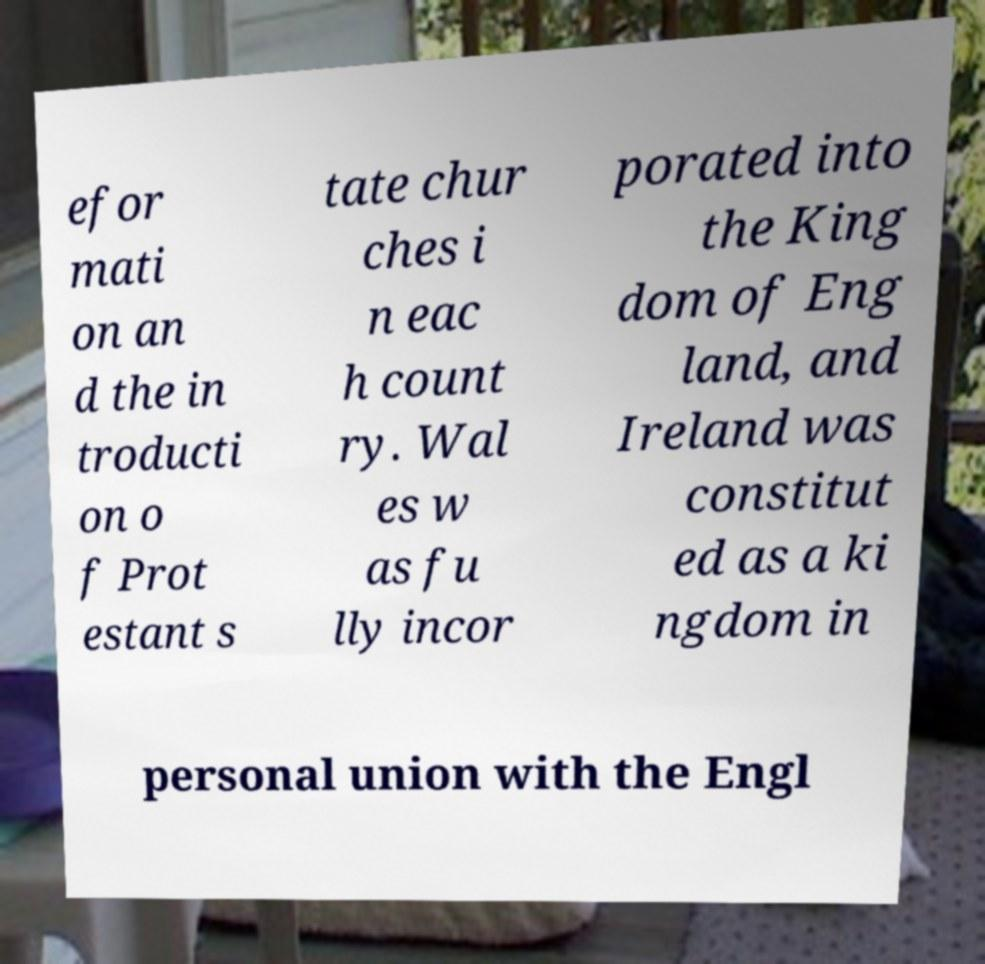Could you assist in decoding the text presented in this image and type it out clearly? efor mati on an d the in troducti on o f Prot estant s tate chur ches i n eac h count ry. Wal es w as fu lly incor porated into the King dom of Eng land, and Ireland was constitut ed as a ki ngdom in personal union with the Engl 